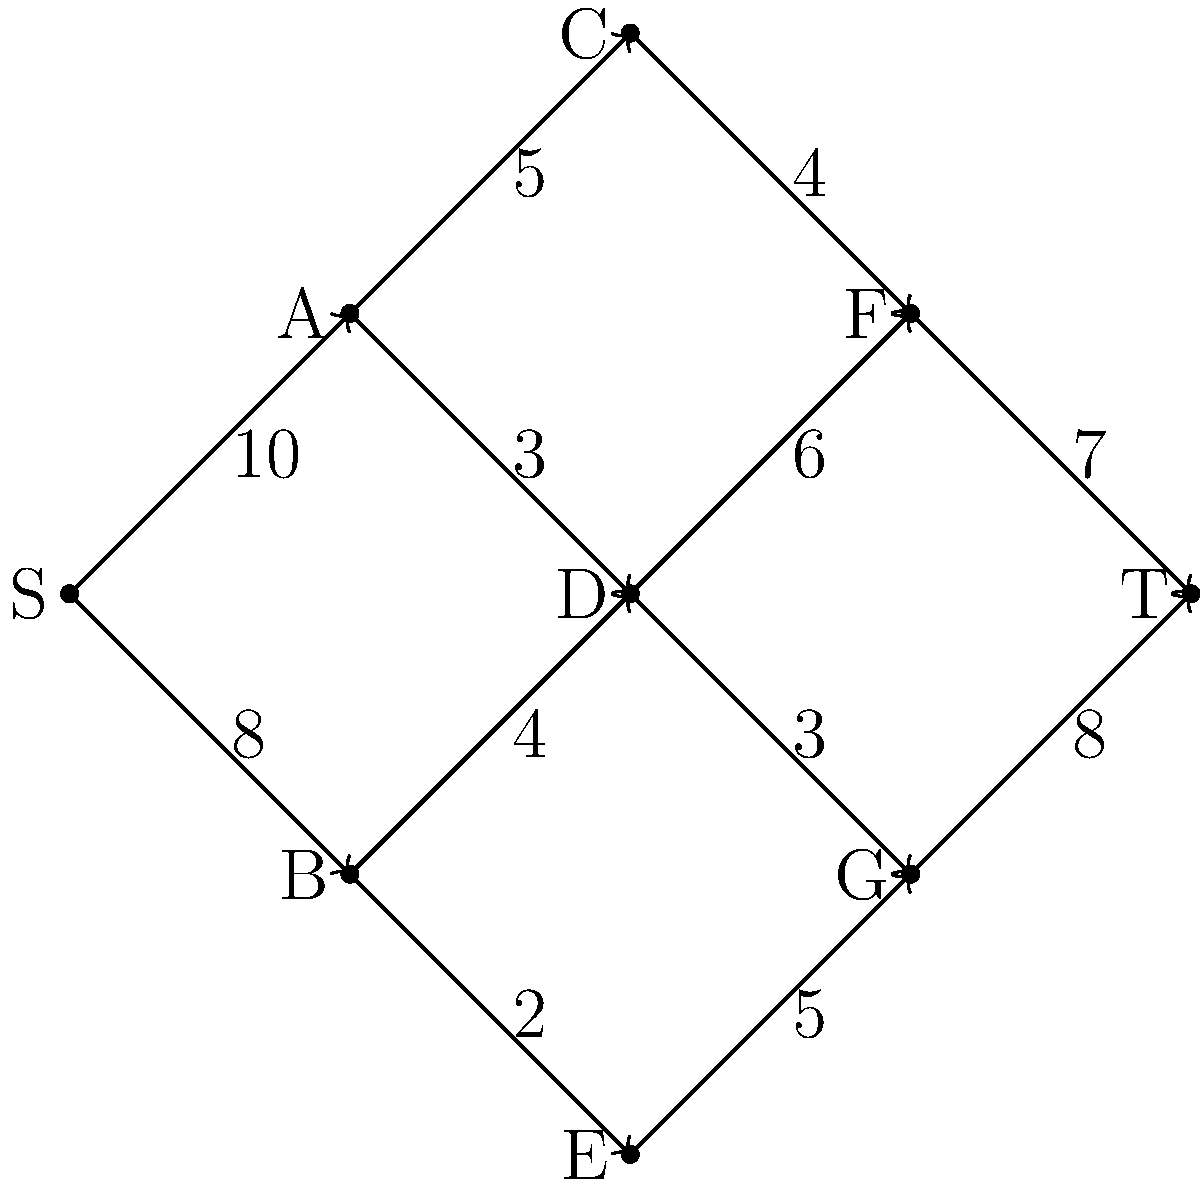In the context of regulatory frameworks for entrepreneurial ventures, the given flow network represents different stages of a business registration process. Each edge capacity indicates the number of applications that can be processed per day at each stage. Identify the minimum cut in this network and explain how it relates to regulatory bottlenecks in the business registration process. To find the minimum cut and identify regulatory bottlenecks, we'll use the Ford-Fulkerson algorithm:

1. Initialize flow to 0 for all edges.

2. Find augmenting paths from S to T and update flows:
   Path 1: S-A-C-F-T (min capacity 4)
   Path 2: S-A-D-F-T (min capacity 3)
   Path 3: S-B-D-G-T (min capacity 3)
   Path 4: S-B-E-G-T (min capacity 2)
   Path 5: S-A-D-G-T (min capacity 1)

3. After these paths, no more augmenting paths exist.

4. The maximum flow is 4 + 3 + 3 + 2 + 1 = 13.

5. To find the minimum cut, mark vertices reachable from S in the residual graph:
   Reachable: S, A, B
   Unreachable: C, D, E, F, G, T

6. The minimum cut consists of edges from reachable to unreachable vertices:
   (A,C) with capacity 5
   (A,D) with capacity 3
   (B,D) with capacity 4
   (B,E) with capacity 2

7. The sum of these capacities is 5 + 3 + 4 + 2 = 14, which equals the max flow (13) plus the remaining capacity (1) on (A,D).

This minimum cut represents the regulatory bottleneck in the business registration process. The stages represented by vertices C, D, and E are the limiting factors, processing a total of 14 applications per day. To improve the process, resources should be allocated to increase capacity at these stages.
Answer: Minimum cut: (A,C), (A,D), (B,D), (B,E); total capacity 14; bottleneck at stages C, D, E 